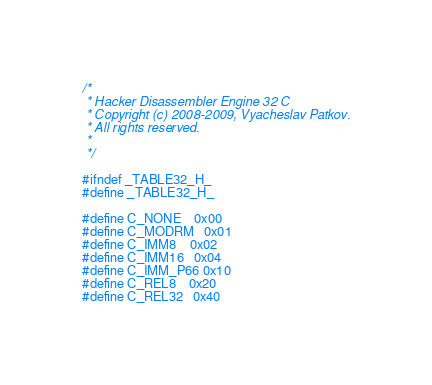<code> <loc_0><loc_0><loc_500><loc_500><_C_>/*
 * Hacker Disassembler Engine 32 C
 * Copyright (c) 2008-2009, Vyacheslav Patkov.
 * All rights reserved.
 *
 */

#ifndef _TABLE32_H_
#define _TABLE32_H_

#define C_NONE    0x00
#define C_MODRM   0x01
#define C_IMM8    0x02
#define C_IMM16   0x04
#define C_IMM_P66 0x10
#define C_REL8    0x20
#define C_REL32   0x40</code> 